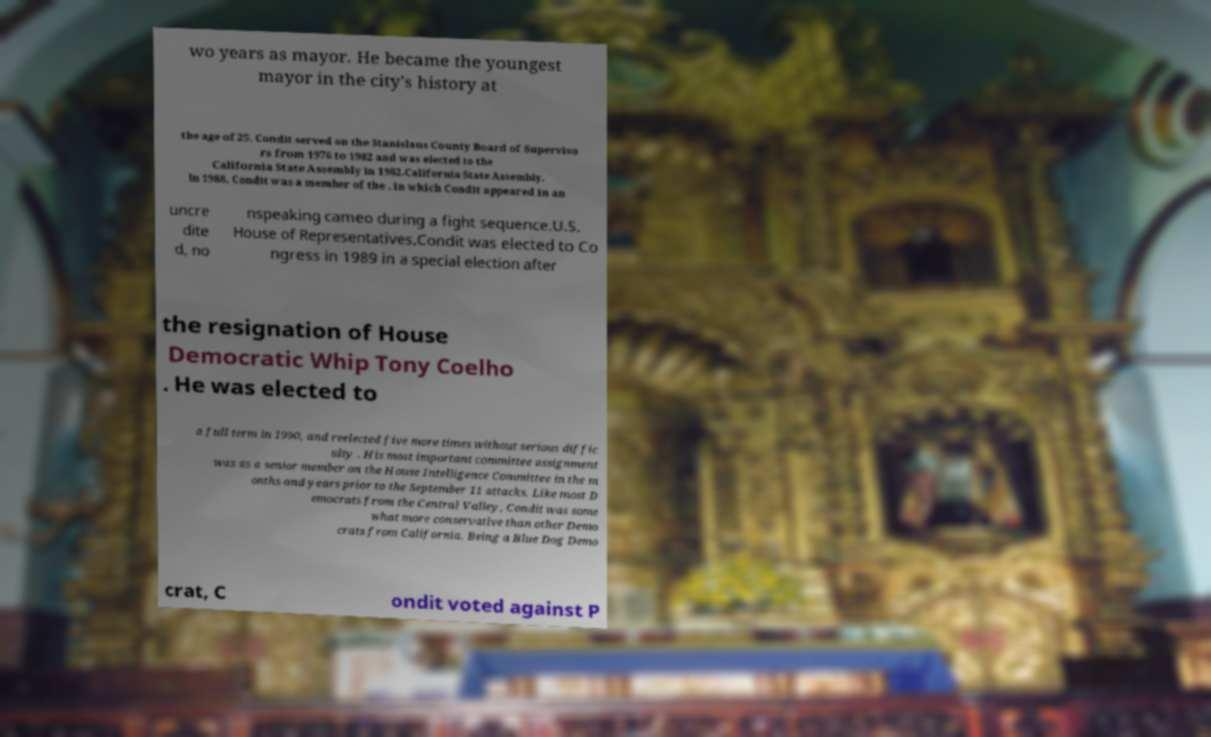Could you extract and type out the text from this image? wo years as mayor. He became the youngest mayor in the city's history at the age of 25. Condit served on the Stanislaus County Board of Superviso rs from 1976 to 1982 and was elected to the California State Assembly in 1982.California State Assembly. In 1988, Condit was a member of the , in which Condit appeared in an uncre dite d, no nspeaking cameo during a fight sequence.U.S. House of Representatives.Condit was elected to Co ngress in 1989 in a special election after the resignation of House Democratic Whip Tony Coelho . He was elected to a full term in 1990, and reelected five more times without serious diffic ulty . His most important committee assignment was as a senior member on the House Intelligence Committee in the m onths and years prior to the September 11 attacks. Like most D emocrats from the Central Valley, Condit was some what more conservative than other Demo crats from California. Being a Blue Dog Demo crat, C ondit voted against P 